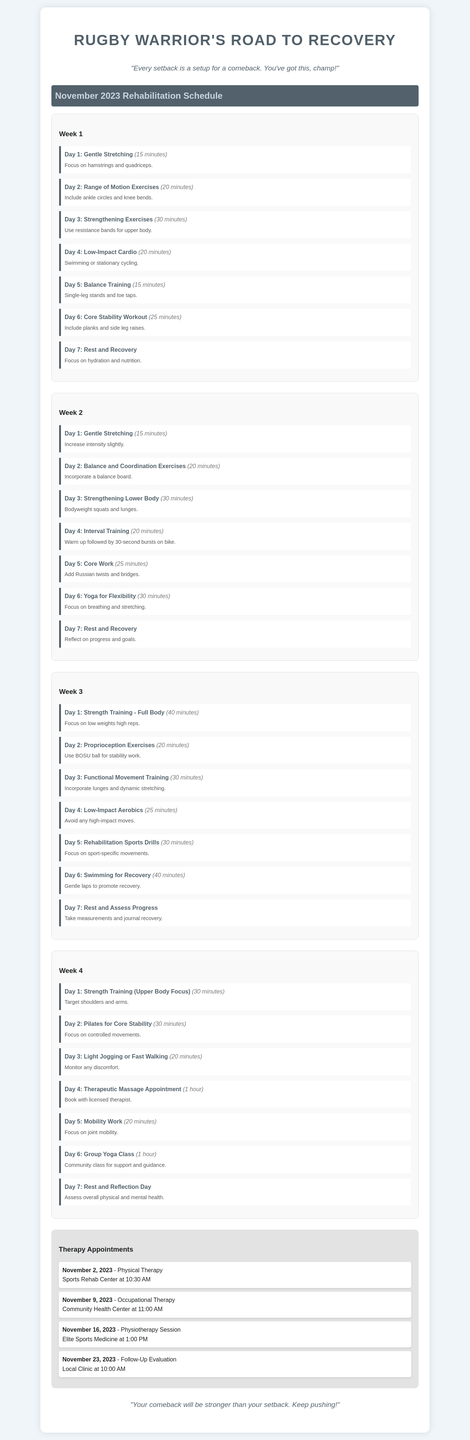what is the title of the document? The title of the document is presented at the top and indicates the focus of the content.
Answer: Rugby Warrior's Road to Recovery what exercise is scheduled for Day 4 of Week 2? The exercise for Day 4 of Week 2 is listed among the daily exercises and describes the focus of that day.
Answer: Interval Training how long is the session for the Therapeutic Massage Appointment? The duration of the appointment is specified next to the exercise in the appointments section.
Answer: 1 hour which appointment occurs on November 16, 2023? The appointment listed on that specific date provides the type of therapy and location for the session.
Answer: Physiotherapy Session how many minutes are allocated for Core Work in Week 2? The duration for this exercise is noted in the schedule alongside the exercise name for that particular day.
Answer: 25 minutes what is the primary focus of Day 3 in Week 1? The focus for that day is provided in the exercise description, outlining what should be practiced.
Answer: Strengthening Exercises which type of yoga class is scheduled for Day 6 of Week 4? This question pertains to the specific category of yoga mentioned in the document on that day.
Answer: Group Yoga Class how many days are allocated for rest and recovery? The number of rest days is based on the outline of the weekly exercises and the specified notes for those days.
Answer: 4 days 